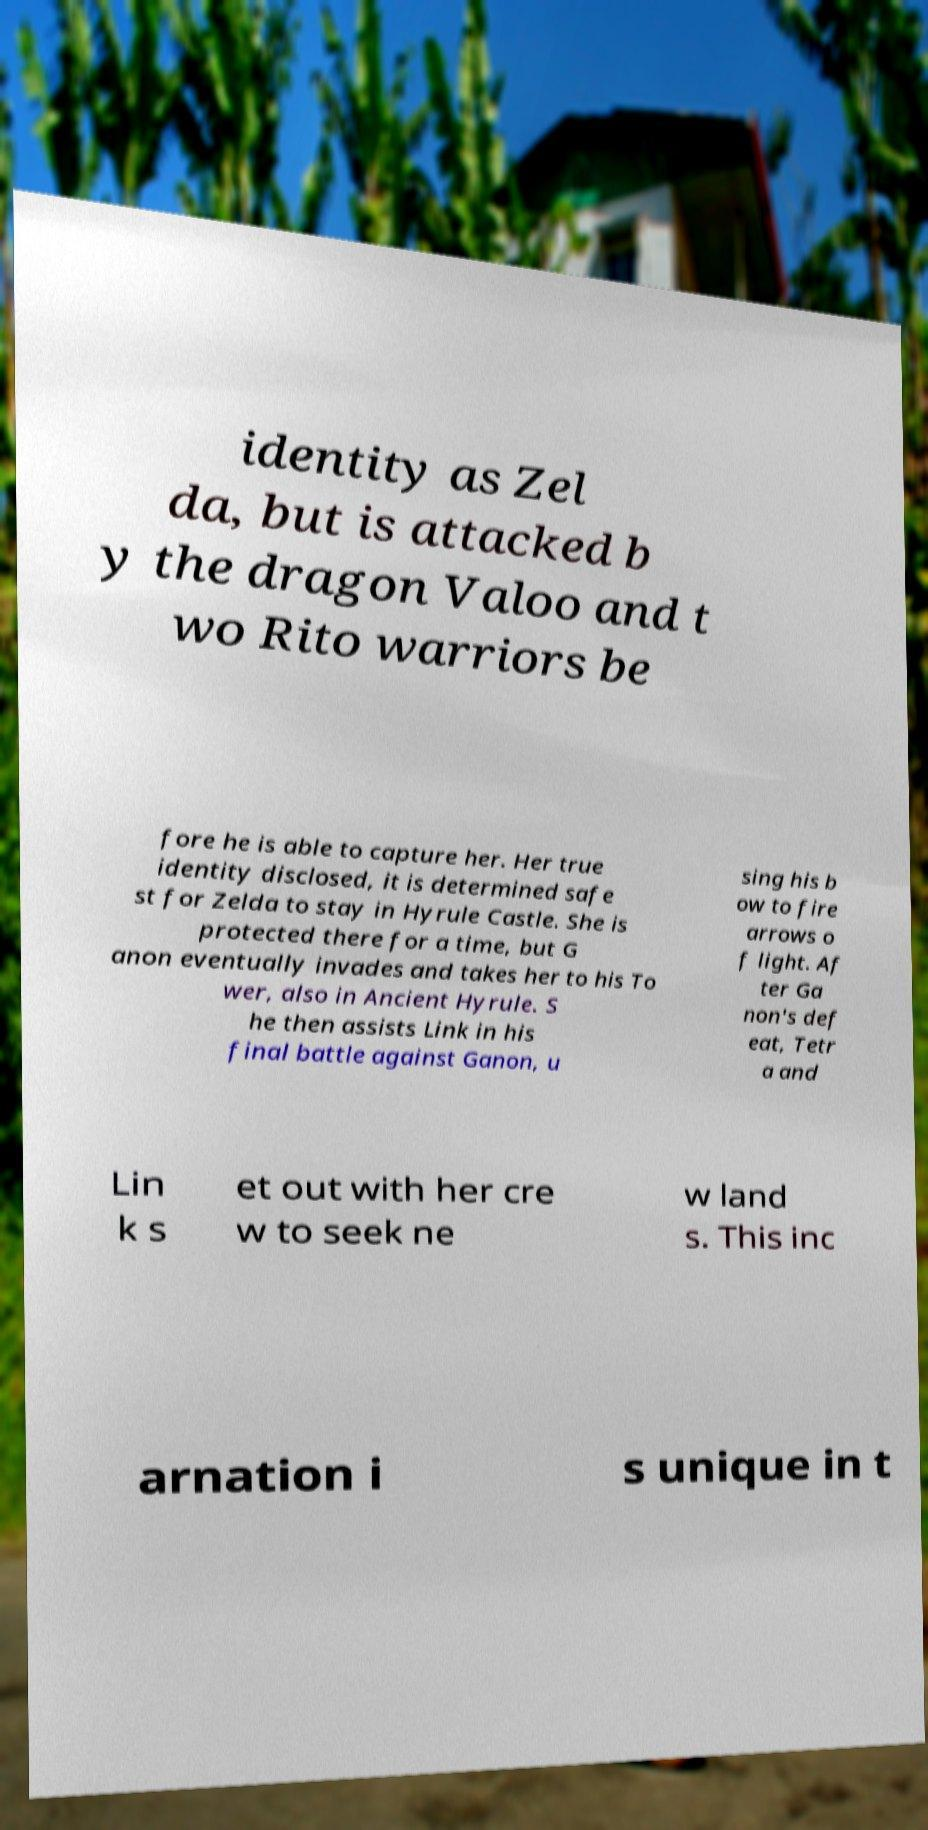Can you accurately transcribe the text from the provided image for me? identity as Zel da, but is attacked b y the dragon Valoo and t wo Rito warriors be fore he is able to capture her. Her true identity disclosed, it is determined safe st for Zelda to stay in Hyrule Castle. She is protected there for a time, but G anon eventually invades and takes her to his To wer, also in Ancient Hyrule. S he then assists Link in his final battle against Ganon, u sing his b ow to fire arrows o f light. Af ter Ga non's def eat, Tetr a and Lin k s et out with her cre w to seek ne w land s. This inc arnation i s unique in t 